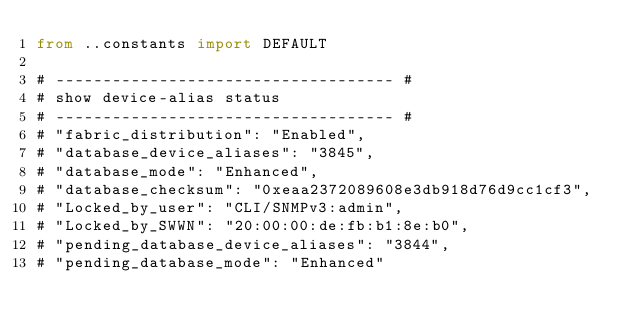<code> <loc_0><loc_0><loc_500><loc_500><_Python_>from ..constants import DEFAULT

# ------------------------------------ #
# show device-alias status
# ------------------------------------ #
# "fabric_distribution": "Enabled",
# "database_device_aliases": "3845",
# "database_mode": "Enhanced",
# "database_checksum": "0xeaa2372089608e3db918d76d9cc1cf3",
# "Locked_by_user": "CLI/SNMPv3:admin",
# "Locked_by_SWWN": "20:00:00:de:fb:b1:8e:b0",
# "pending_database_device_aliases": "3844",
# "pending_database_mode": "Enhanced"</code> 